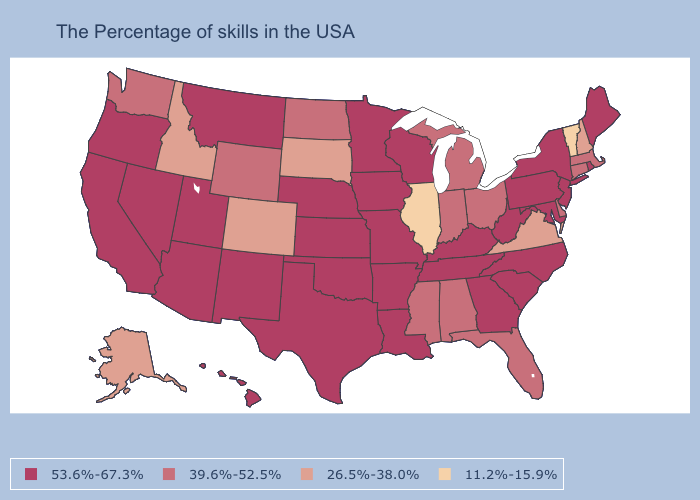Which states have the lowest value in the USA?
Answer briefly. Vermont, Illinois. What is the lowest value in the West?
Keep it brief. 26.5%-38.0%. What is the highest value in the West ?
Concise answer only. 53.6%-67.3%. What is the value of Alabama?
Keep it brief. 39.6%-52.5%. Does Arkansas have a higher value than Tennessee?
Short answer required. No. What is the value of New York?
Short answer required. 53.6%-67.3%. What is the value of New Mexico?
Give a very brief answer. 53.6%-67.3%. Does the first symbol in the legend represent the smallest category?
Give a very brief answer. No. Name the states that have a value in the range 26.5%-38.0%?
Write a very short answer. New Hampshire, Virginia, South Dakota, Colorado, Idaho, Alaska. What is the value of Alabama?
Give a very brief answer. 39.6%-52.5%. Name the states that have a value in the range 26.5%-38.0%?
Concise answer only. New Hampshire, Virginia, South Dakota, Colorado, Idaho, Alaska. Does Connecticut have the same value as Delaware?
Give a very brief answer. Yes. Name the states that have a value in the range 39.6%-52.5%?
Give a very brief answer. Massachusetts, Connecticut, Delaware, Ohio, Florida, Michigan, Indiana, Alabama, Mississippi, North Dakota, Wyoming, Washington. Name the states that have a value in the range 53.6%-67.3%?
Keep it brief. Maine, Rhode Island, New York, New Jersey, Maryland, Pennsylvania, North Carolina, South Carolina, West Virginia, Georgia, Kentucky, Tennessee, Wisconsin, Louisiana, Missouri, Arkansas, Minnesota, Iowa, Kansas, Nebraska, Oklahoma, Texas, New Mexico, Utah, Montana, Arizona, Nevada, California, Oregon, Hawaii. What is the lowest value in the USA?
Answer briefly. 11.2%-15.9%. 